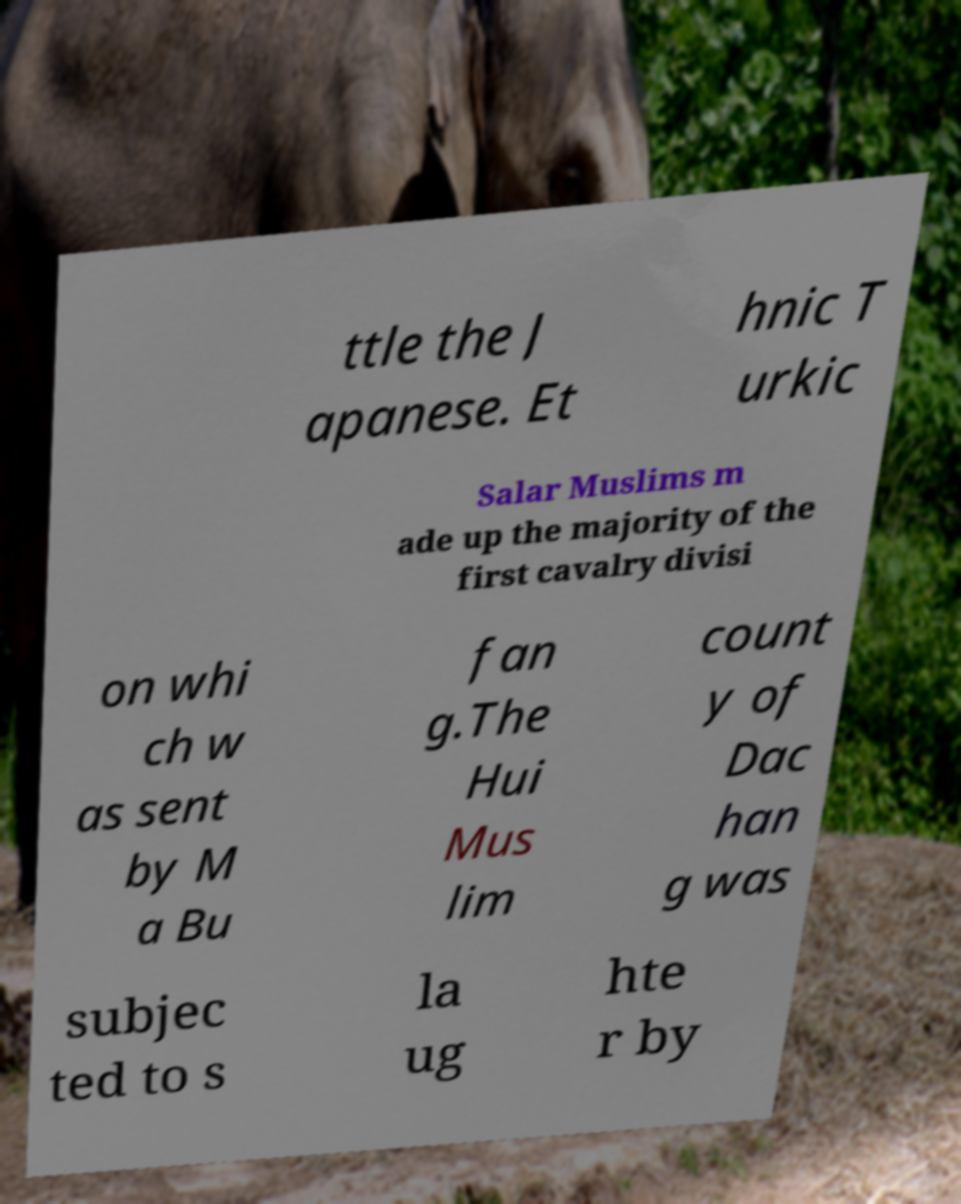Can you accurately transcribe the text from the provided image for me? ttle the J apanese. Et hnic T urkic Salar Muslims m ade up the majority of the first cavalry divisi on whi ch w as sent by M a Bu fan g.The Hui Mus lim count y of Dac han g was subjec ted to s la ug hte r by 